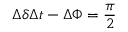<formula> <loc_0><loc_0><loc_500><loc_500>\Delta \delta \Delta t - \Delta \Phi = \frac { \pi } { 2 }</formula> 